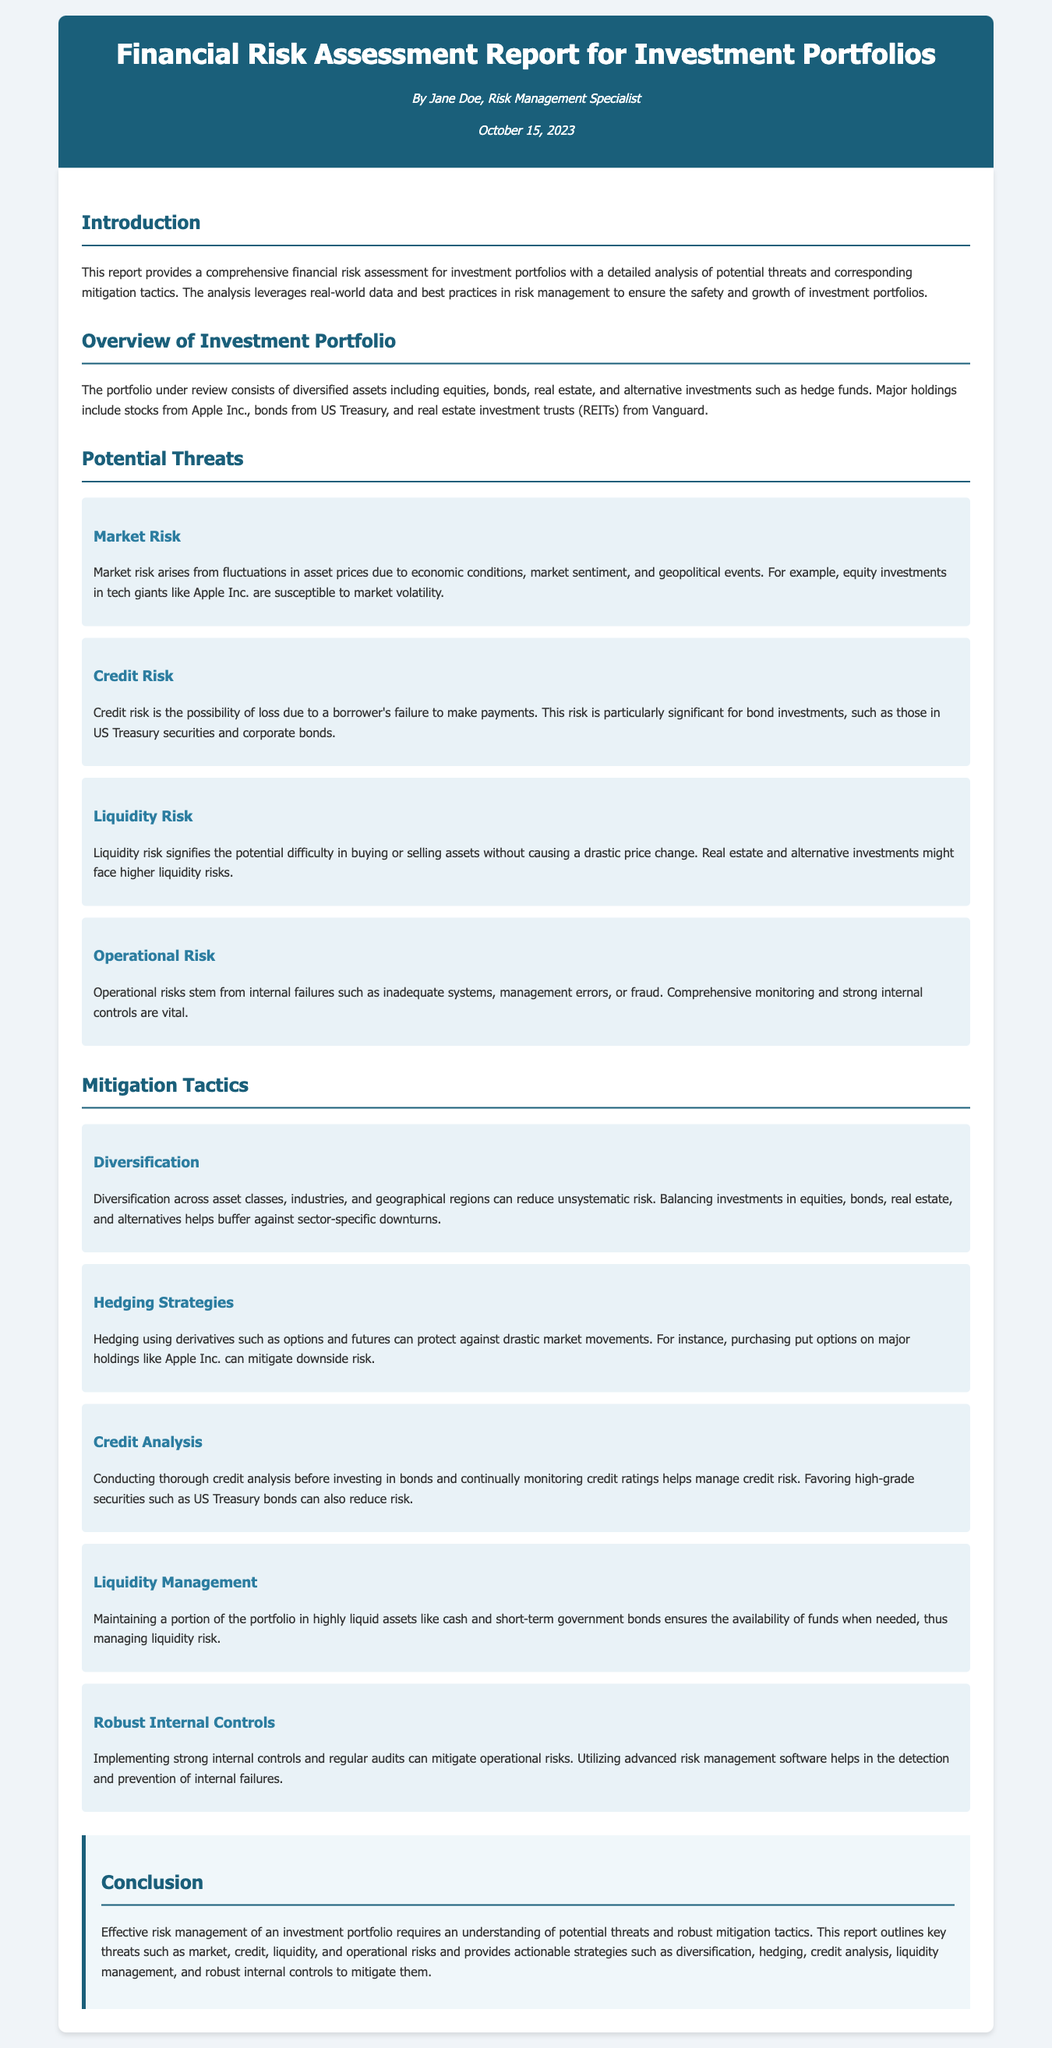What is the title of the report? The title of the report is clearly stated at the beginning of the document.
Answer: Financial Risk Assessment Report for Investment Portfolios Who authored the report? The author's name is listed in the header section of the document.
Answer: Jane Doe What date was the report published? The publication date is provided under the author name in the header.
Answer: October 15, 2023 What type of assets are included in the portfolio? The document outlines the types of assets reviewed for risk assessment.
Answer: Equities, bonds, real estate, alternative investments What is one example of market risk mentioned in the report? The report specifically mentions a company whose equity investments are susceptible to market volatility.
Answer: Apple Inc Which strategy is suggested to manage liquidity risk? The report outlines a specific tactic for ensuring availability of funds in the portfolio management section.
Answer: Maintaining a portion of the portfolio in highly liquid assets What is one benefit of diversification according to the document? The document states a significant advantage of diversification in risk management.
Answer: Reduces unsystematic risk What is the focus of the conclusion section? The conclusion summarizes the key themes and strategies highlighted throughout the report.
Answer: Effective risk management strategies for investment portfolios 